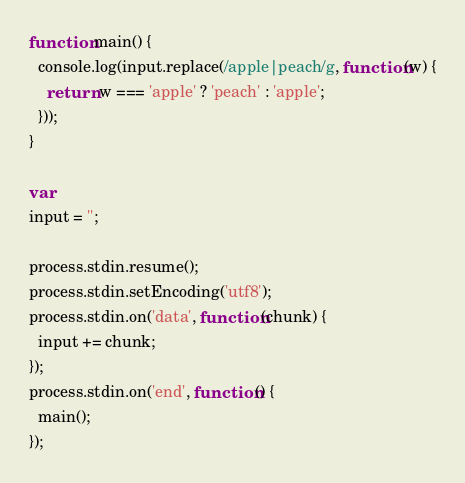<code> <loc_0><loc_0><loc_500><loc_500><_JavaScript_>function main() {
  console.log(input.replace(/apple|peach/g, function(w) {
    return w === 'apple' ? 'peach' : 'apple';
  }));
}

var
input = '';

process.stdin.resume();
process.stdin.setEncoding('utf8');
process.stdin.on('data', function(chunk) {
  input += chunk;
});
process.stdin.on('end', function() {
  main();
});</code> 